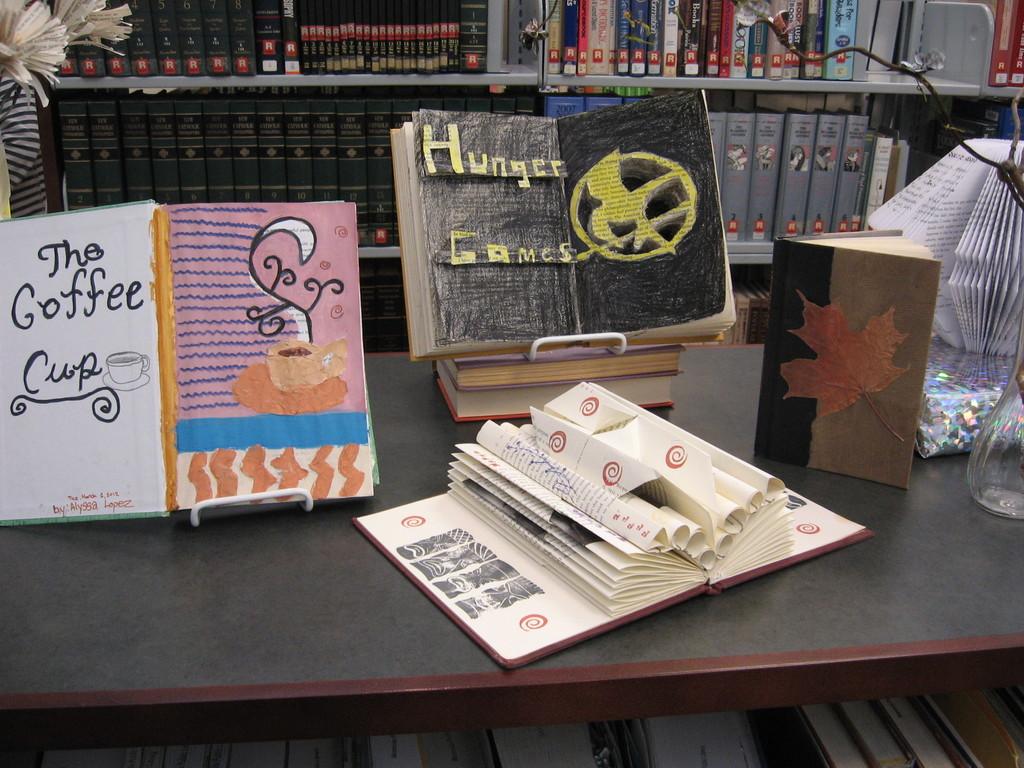What are the names of the two books?
Provide a succinct answer. The coffee cup, hunger games. Which book did alyssa lopez author?
Keep it short and to the point. The coffee cup. 